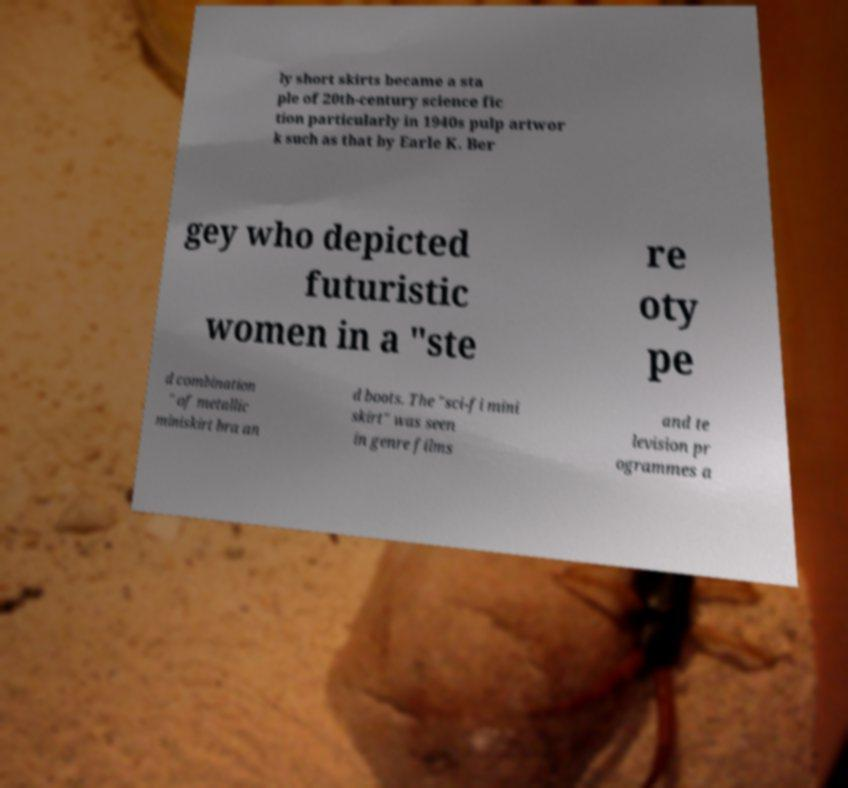Could you assist in decoding the text presented in this image and type it out clearly? ly short skirts became a sta ple of 20th-century science fic tion particularly in 1940s pulp artwor k such as that by Earle K. Ber gey who depicted futuristic women in a "ste re oty pe d combination " of metallic miniskirt bra an d boots. The "sci-fi mini skirt" was seen in genre films and te levision pr ogrammes a 